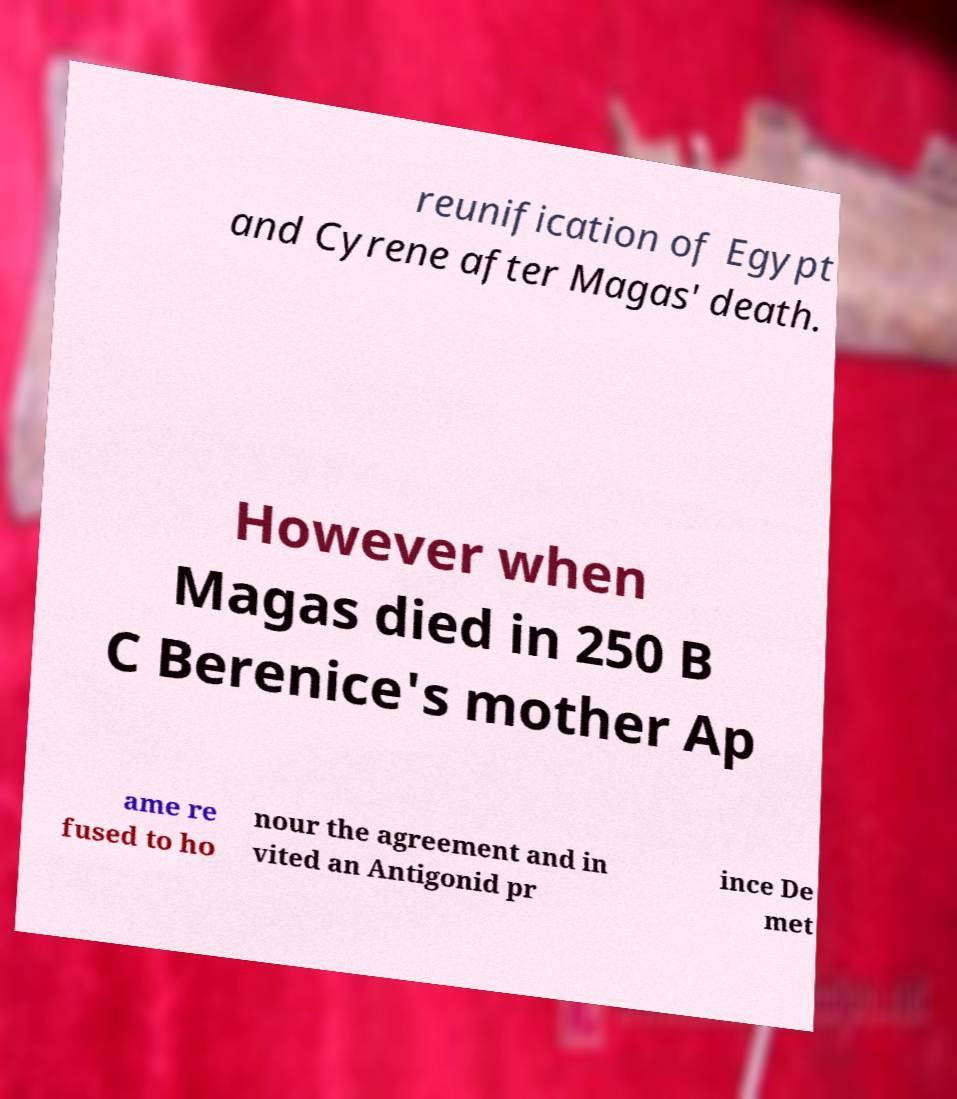What messages or text are displayed in this image? I need them in a readable, typed format. reunification of Egypt and Cyrene after Magas' death. However when Magas died in 250 B C Berenice's mother Ap ame re fused to ho nour the agreement and in vited an Antigonid pr ince De met 